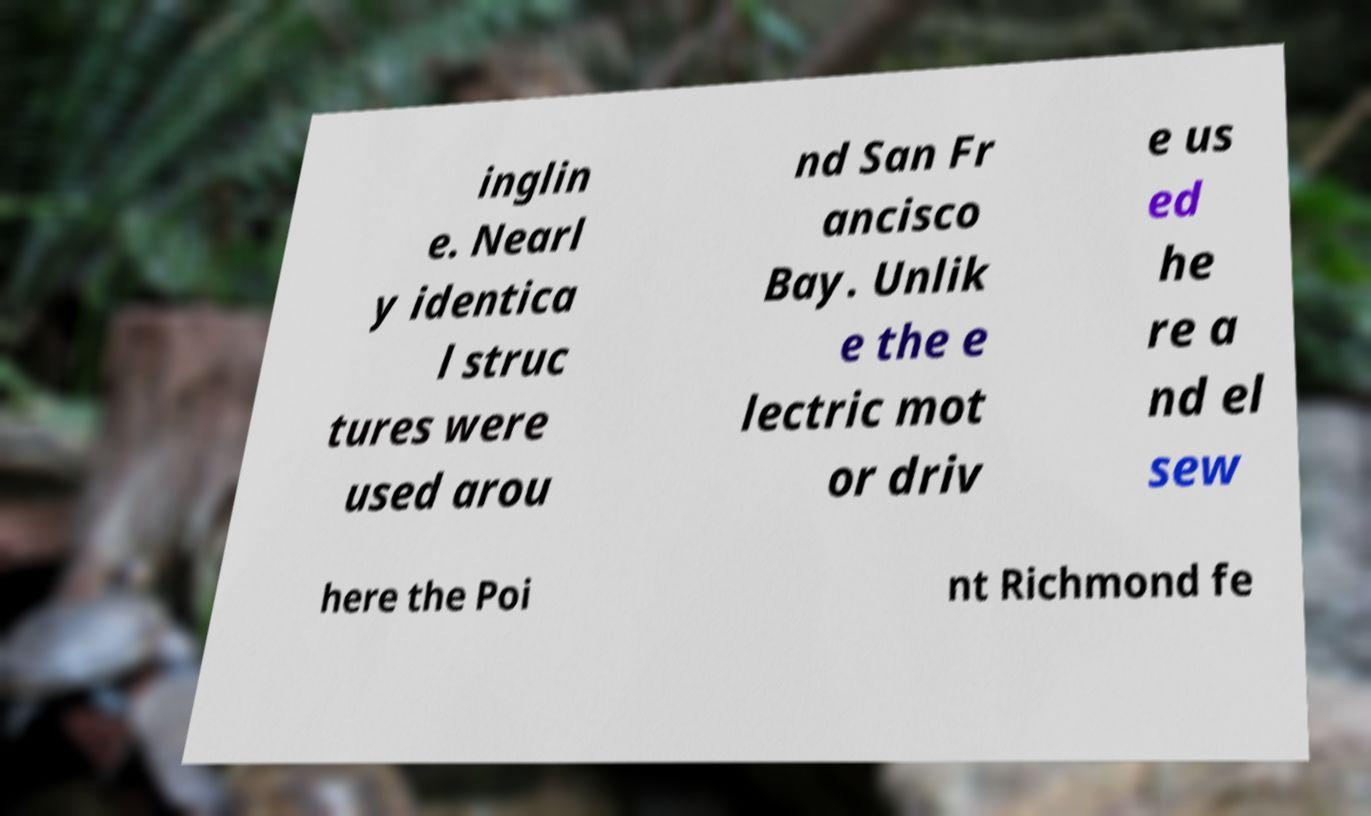For documentation purposes, I need the text within this image transcribed. Could you provide that? inglin e. Nearl y identica l struc tures were used arou nd San Fr ancisco Bay. Unlik e the e lectric mot or driv e us ed he re a nd el sew here the Poi nt Richmond fe 